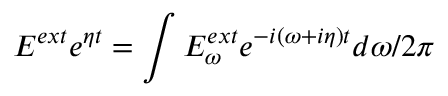Convert formula to latex. <formula><loc_0><loc_0><loc_500><loc_500>E ^ { e x t } e ^ { \eta t } = \int E _ { \omega } ^ { e x t } e ^ { - i ( \omega + i \eta ) t } d \omega / 2 \pi</formula> 